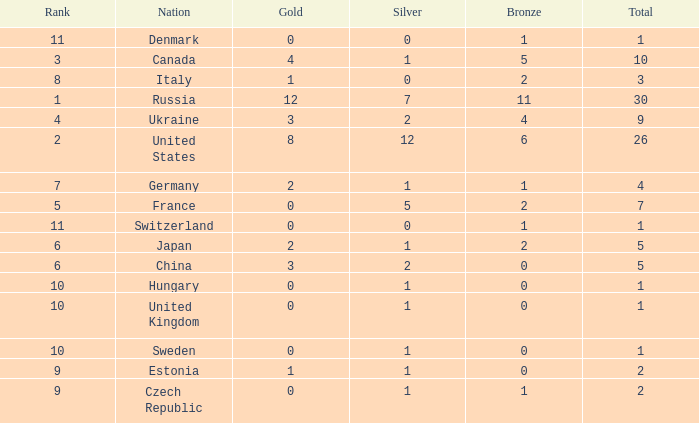What is the largest silver with Gold larger than 4, a Nation of united states, and a Total larger than 26? None. 